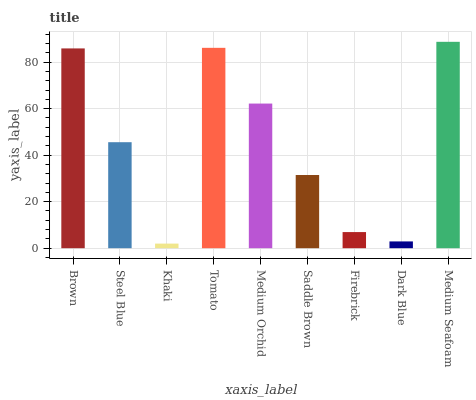Is Steel Blue the minimum?
Answer yes or no. No. Is Steel Blue the maximum?
Answer yes or no. No. Is Brown greater than Steel Blue?
Answer yes or no. Yes. Is Steel Blue less than Brown?
Answer yes or no. Yes. Is Steel Blue greater than Brown?
Answer yes or no. No. Is Brown less than Steel Blue?
Answer yes or no. No. Is Steel Blue the high median?
Answer yes or no. Yes. Is Steel Blue the low median?
Answer yes or no. Yes. Is Medium Orchid the high median?
Answer yes or no. No. Is Medium Seafoam the low median?
Answer yes or no. No. 